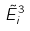Convert formula to latex. <formula><loc_0><loc_0><loc_500><loc_500>\tilde { E } _ { i } ^ { 3 }</formula> 